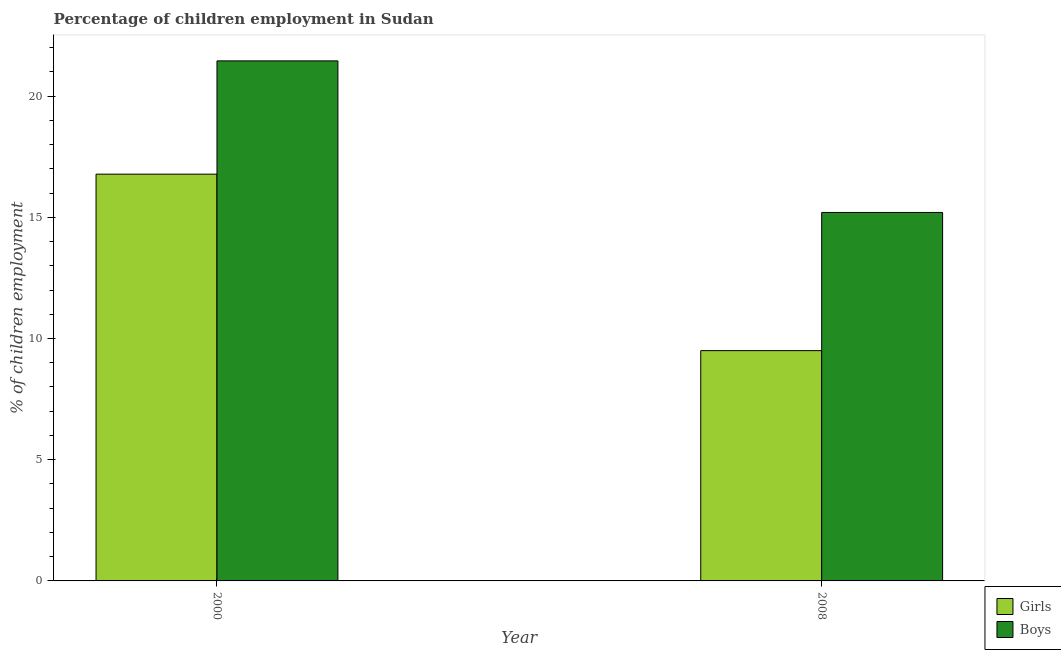How many groups of bars are there?
Provide a short and direct response. 2. How many bars are there on the 2nd tick from the left?
Keep it short and to the point. 2. How many bars are there on the 2nd tick from the right?
Your answer should be very brief. 2. In how many cases, is the number of bars for a given year not equal to the number of legend labels?
Your response must be concise. 0. Across all years, what is the maximum percentage of employed boys?
Your answer should be compact. 21.45. In which year was the percentage of employed boys maximum?
Make the answer very short. 2000. What is the total percentage of employed boys in the graph?
Your response must be concise. 36.65. What is the difference between the percentage of employed girls in 2000 and that in 2008?
Give a very brief answer. 7.28. What is the difference between the percentage of employed boys in 2008 and the percentage of employed girls in 2000?
Ensure brevity in your answer.  -6.25. What is the average percentage of employed girls per year?
Make the answer very short. 13.14. What is the ratio of the percentage of employed boys in 2000 to that in 2008?
Offer a very short reply. 1.41. Is the percentage of employed girls in 2000 less than that in 2008?
Offer a terse response. No. In how many years, is the percentage of employed girls greater than the average percentage of employed girls taken over all years?
Your response must be concise. 1. What does the 2nd bar from the left in 2008 represents?
Ensure brevity in your answer.  Boys. What does the 1st bar from the right in 2008 represents?
Keep it short and to the point. Boys. Are all the bars in the graph horizontal?
Your answer should be compact. No. What is the difference between two consecutive major ticks on the Y-axis?
Give a very brief answer. 5. Are the values on the major ticks of Y-axis written in scientific E-notation?
Make the answer very short. No. Does the graph contain grids?
Make the answer very short. No. What is the title of the graph?
Keep it short and to the point. Percentage of children employment in Sudan. What is the label or title of the Y-axis?
Provide a short and direct response. % of children employment. What is the % of children employment of Girls in 2000?
Your answer should be compact. 16.78. What is the % of children employment of Boys in 2000?
Your answer should be compact. 21.45. What is the % of children employment of Girls in 2008?
Your answer should be very brief. 9.5. Across all years, what is the maximum % of children employment in Girls?
Ensure brevity in your answer.  16.78. Across all years, what is the maximum % of children employment of Boys?
Offer a terse response. 21.45. What is the total % of children employment in Girls in the graph?
Give a very brief answer. 26.28. What is the total % of children employment of Boys in the graph?
Your response must be concise. 36.65. What is the difference between the % of children employment of Girls in 2000 and that in 2008?
Provide a short and direct response. 7.28. What is the difference between the % of children employment in Boys in 2000 and that in 2008?
Your response must be concise. 6.25. What is the difference between the % of children employment of Girls in 2000 and the % of children employment of Boys in 2008?
Your answer should be very brief. 1.58. What is the average % of children employment in Girls per year?
Offer a very short reply. 13.14. What is the average % of children employment in Boys per year?
Give a very brief answer. 18.33. In the year 2000, what is the difference between the % of children employment of Girls and % of children employment of Boys?
Your answer should be compact. -4.67. What is the ratio of the % of children employment in Girls in 2000 to that in 2008?
Ensure brevity in your answer.  1.77. What is the ratio of the % of children employment of Boys in 2000 to that in 2008?
Your response must be concise. 1.41. What is the difference between the highest and the second highest % of children employment of Girls?
Ensure brevity in your answer.  7.28. What is the difference between the highest and the second highest % of children employment of Boys?
Your answer should be very brief. 6.25. What is the difference between the highest and the lowest % of children employment of Girls?
Your answer should be compact. 7.28. What is the difference between the highest and the lowest % of children employment of Boys?
Your response must be concise. 6.25. 